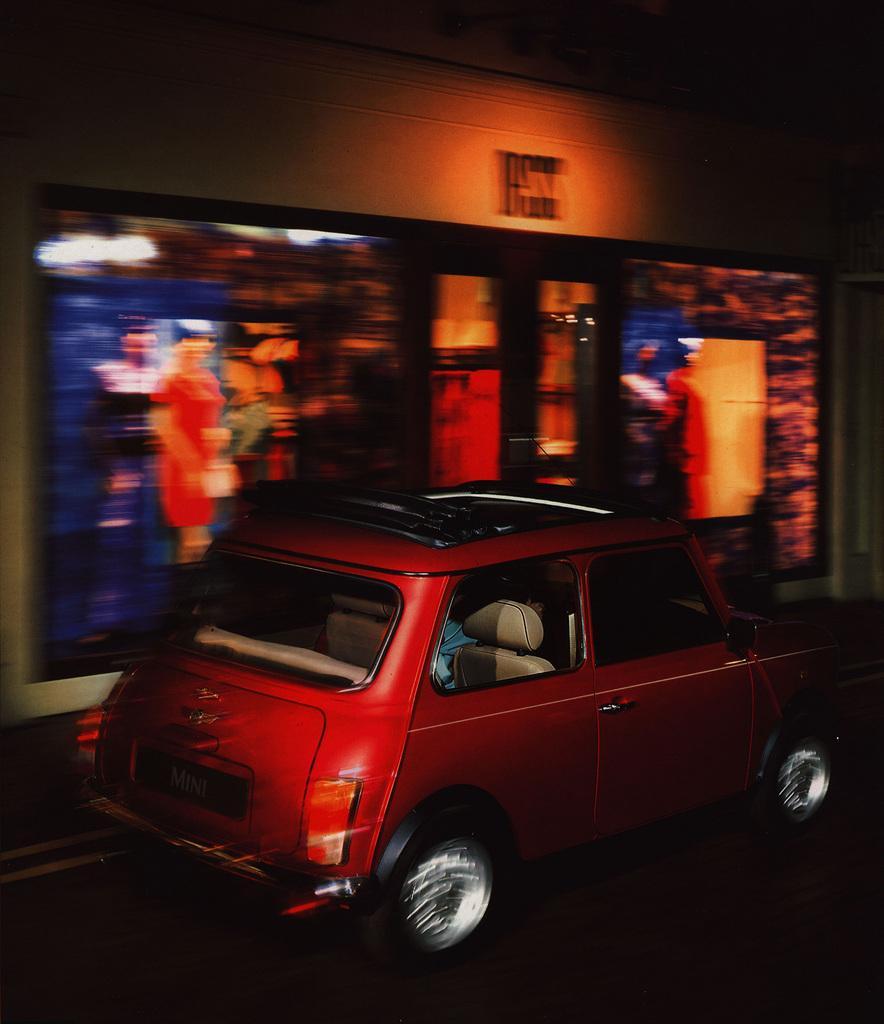Can you describe this image briefly? There is a red color vehicle on the road near hoarding. In the background, there is a photo frame on the wall. And the background is dark in color. 